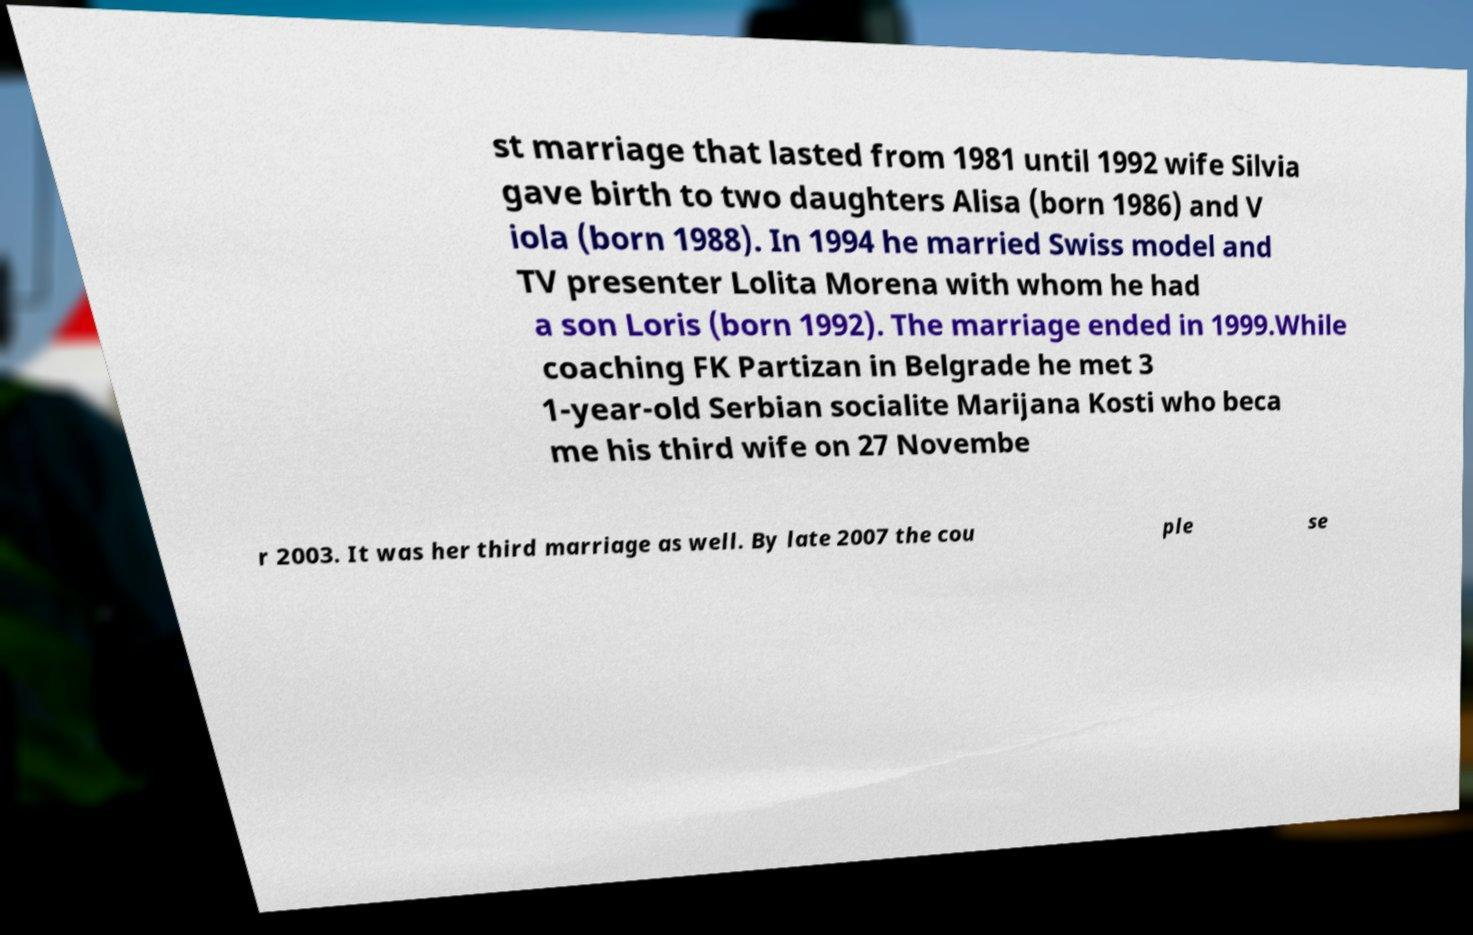For documentation purposes, I need the text within this image transcribed. Could you provide that? st marriage that lasted from 1981 until 1992 wife Silvia gave birth to two daughters Alisa (born 1986) and V iola (born 1988). In 1994 he married Swiss model and TV presenter Lolita Morena with whom he had a son Loris (born 1992). The marriage ended in 1999.While coaching FK Partizan in Belgrade he met 3 1-year-old Serbian socialite Marijana Kosti who beca me his third wife on 27 Novembe r 2003. It was her third marriage as well. By late 2007 the cou ple se 